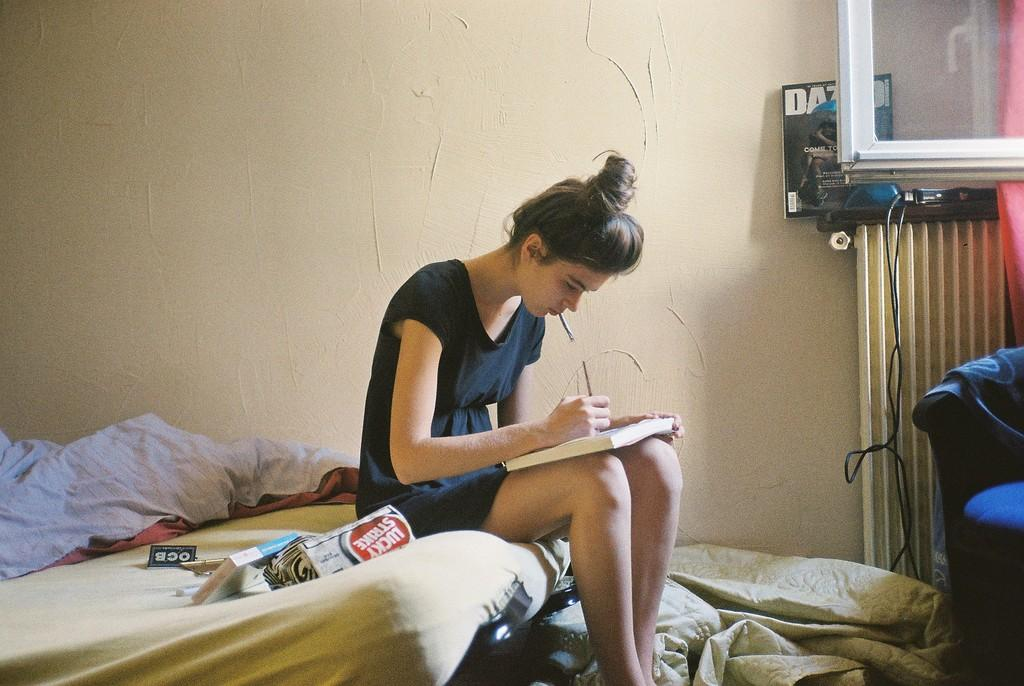What is the person in the image doing? The person is sitting on a bed. What is the person wearing? The person is wearing a black dress. What is the person holding? The person is holding a book. Are there any other books visible in the image? Yes, there is a book on the bed. What else is on the bed? There is a blanket on the bed. What can be seen at the right side of the image? There is a wire and a window at the right side of the image. What type of pan is visible on the bed in the image? There is no pan visible in the image; it features a person sitting on a bed with a book and a blanket. 